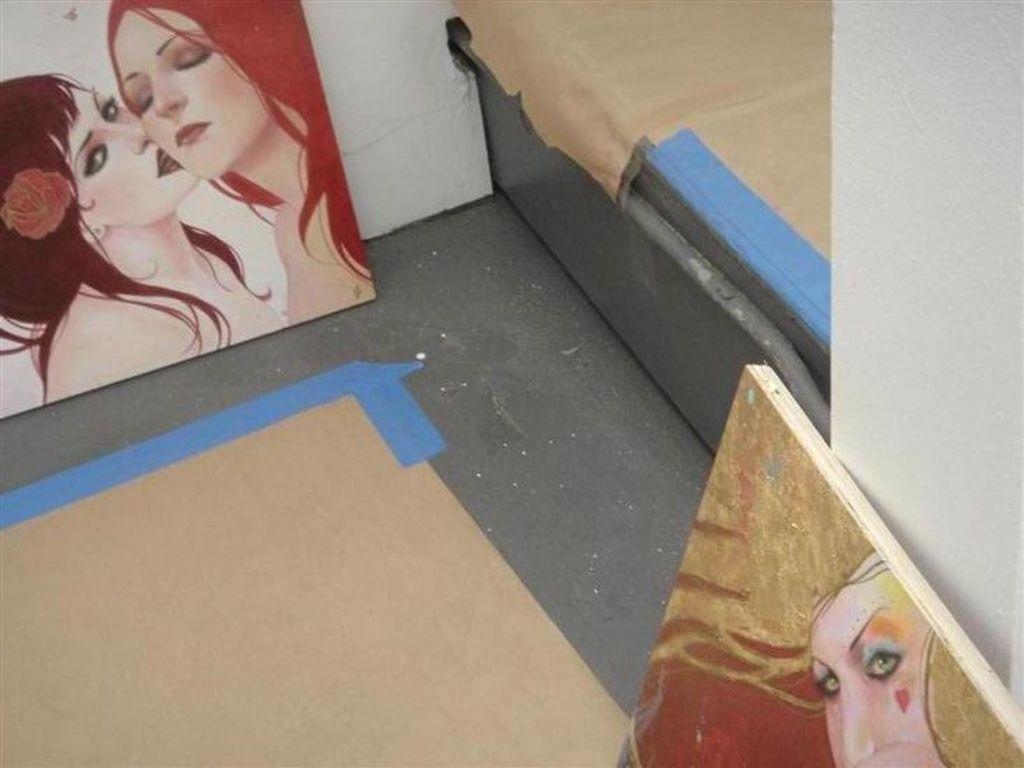Can you describe this image briefly? In this image, at the left side we can see a painting and there are two women in that painting, at the right side there is another painting, in the background there is a white color wall. 